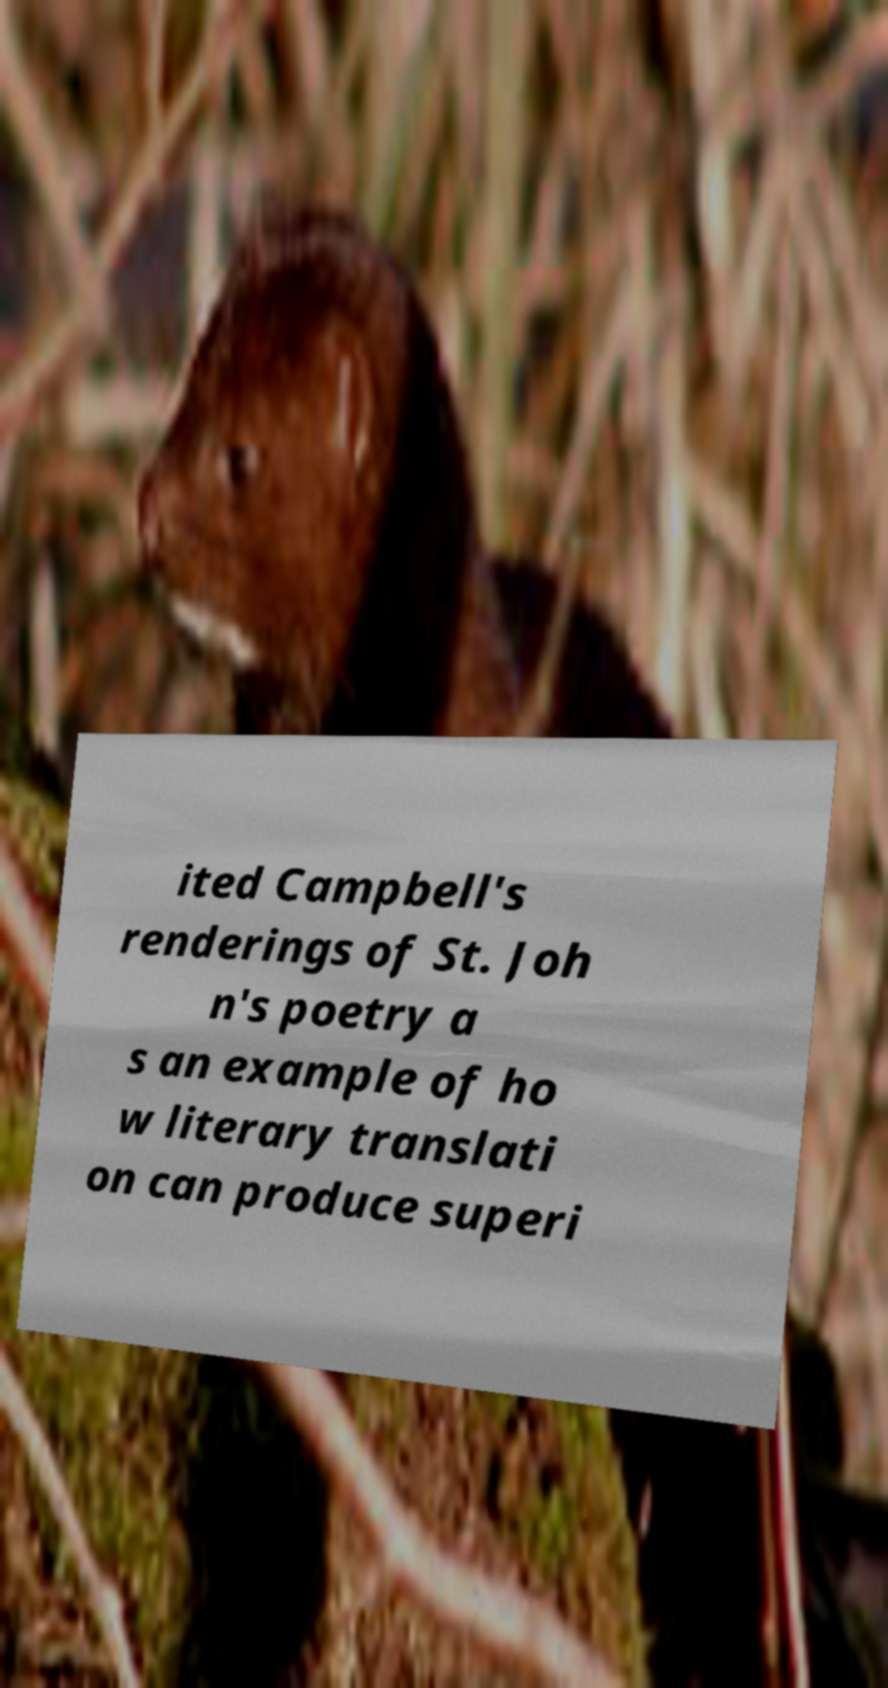Could you assist in decoding the text presented in this image and type it out clearly? ited Campbell's renderings of St. Joh n's poetry a s an example of ho w literary translati on can produce superi 